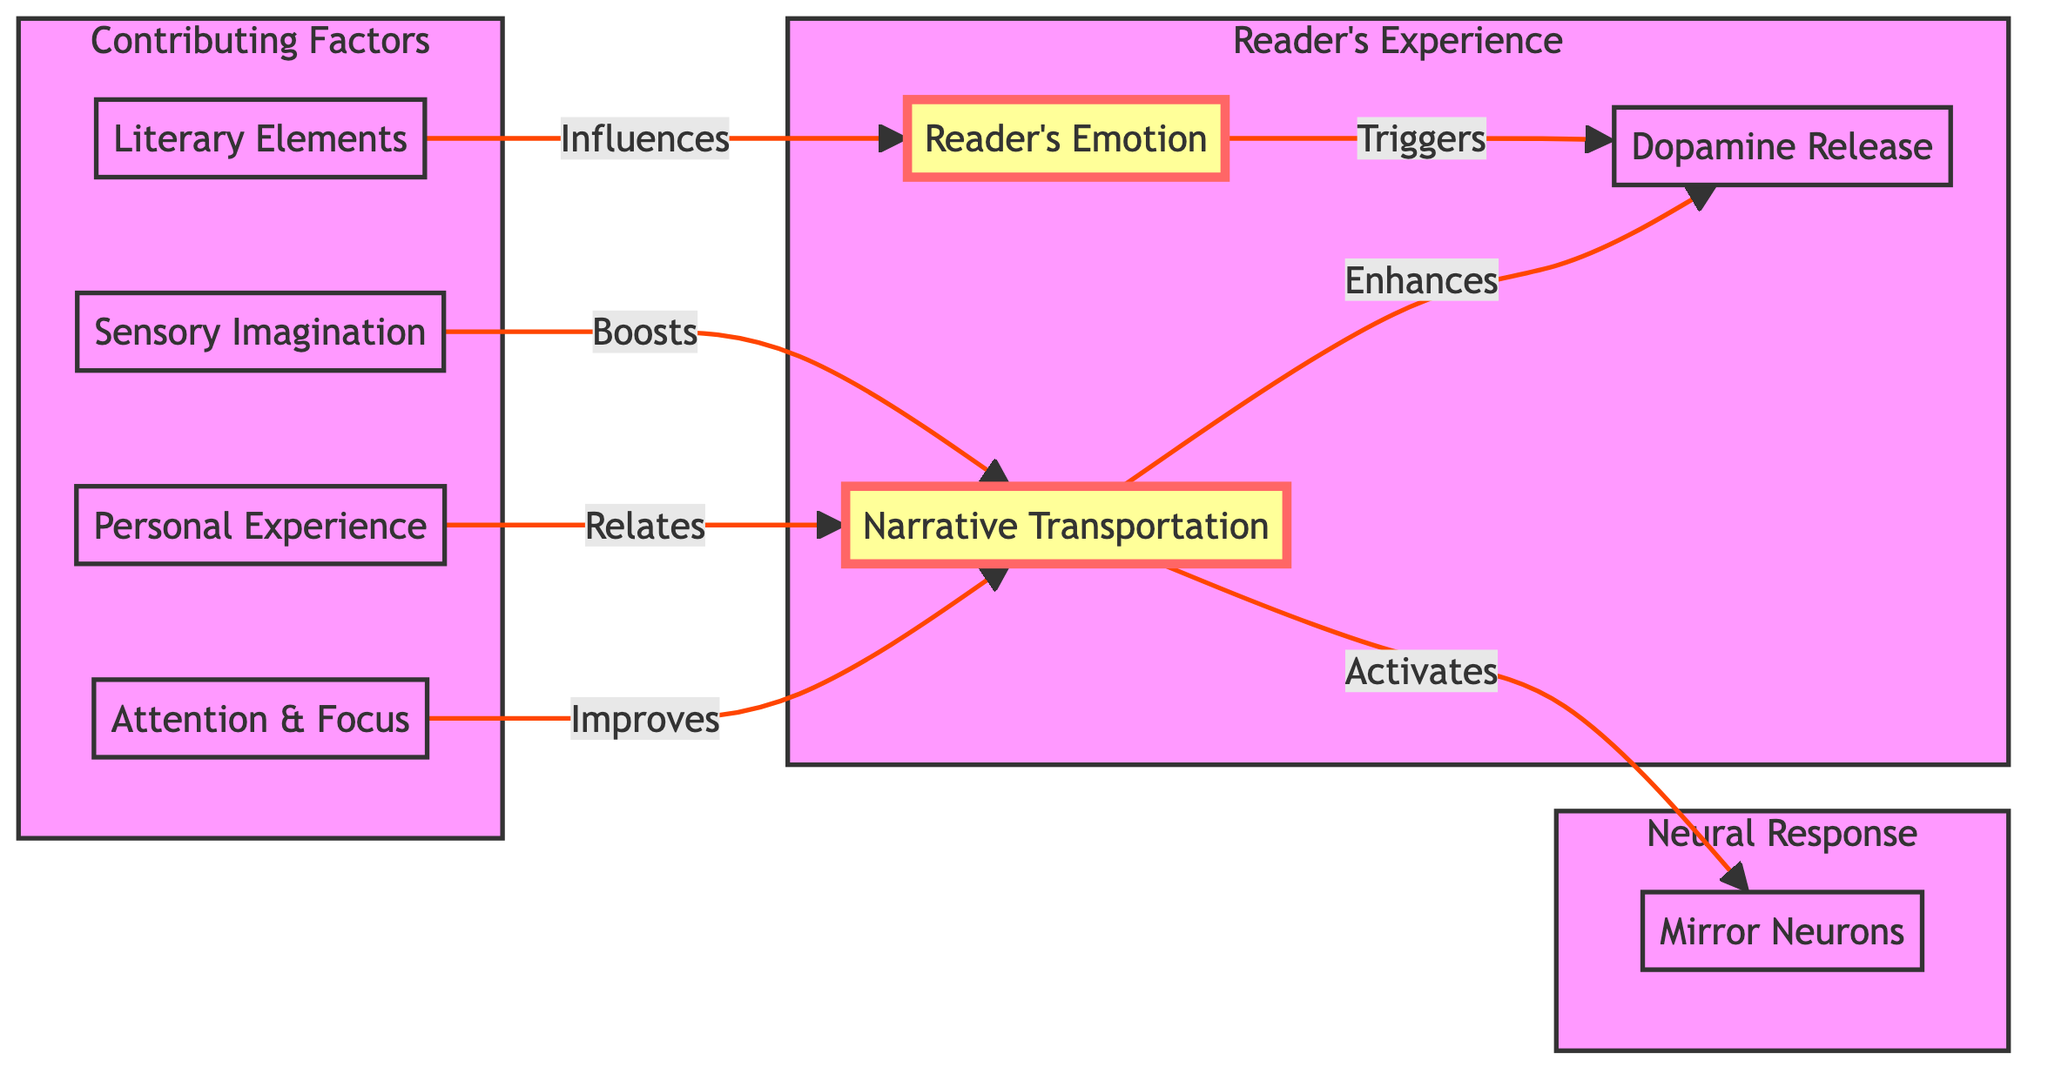What influences the reader's emotion? According to the diagram, literary elements are shown to influence the reader's emotion. This direct connection indicates that the components of storytelling, including plot, character development, and style, contribute to how a reader feels when engaging with a text.
Answer: literary elements What is activated by narrative transportation? The diagram shows that narrative transportation activates mirror neurons. This indicates that this mental state, where the reader is absorbed in the story, triggers the same neural responses that occur when experiencing events personally.
Answer: mirror neurons How many contributing factors are listed in the diagram? The diagram includes four contributing factors: literary elements, sensory imagination, personal experience, and attention and focus. By counting these nodes in the "Factors" subgraph, we find that there are a total of four elements that contribute to reader engagement.
Answer: four What is boosted by sensory imagination? The diagram states that sensory imagination boosts narrative transportation. This means that the ability to visualize and engage with the sensory aspects of a story heightens the reader's immersive experience, leading to greater emotional and cognitive engagement.
Answer: narrative transportation How does reader emotion relate to dopamine release? The diagram indicates that reader emotion triggers dopamine release. This relationship suggests that when a reader experiences strong emotions, it leads to the release of dopamine, a neurotransmitter associated with pleasure and reward, enhancing the reading experience.
Answer: triggers What enhances dopamine release? The diagram shows that narrative transportation enhances dopamine release. This implies that when a reader is fully engaged and immersed in the narrative, it increases the likelihood of dopamine being released, thereby heightening enjoyment and satisfaction from reading.
Answer: enhances How many edges are present in the diagram? To determine the number of edges, we can look at the connections between the nodes. There are a total of 7 directed connections (or edges) that display the relationships between various elements of reader engagement as illustrated in the diagram.
Answer: seven Which factor relates to narrative transportation? The diagram specifies that personal experience relates to narrative transportation. This indicates that a reader's own life experiences can influence the degree to which they become immersed in a story, enhancing their overall engagement.
Answer: personal experience What is the role of attention and focus? The diagram indicates that attention and focus improve narrative transportation. This means that when readers concentrate on the text, it significantly enhances their ability to become absorbed in the story, leading to a better reading experience.
Answer: improves 